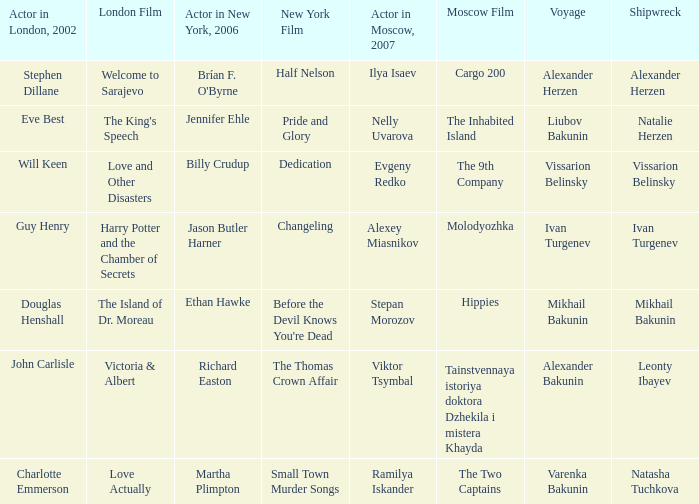Who was the 2007 thespian from moscow for the maritime disaster of leonty ibayev? Viktor Tsymbal. 